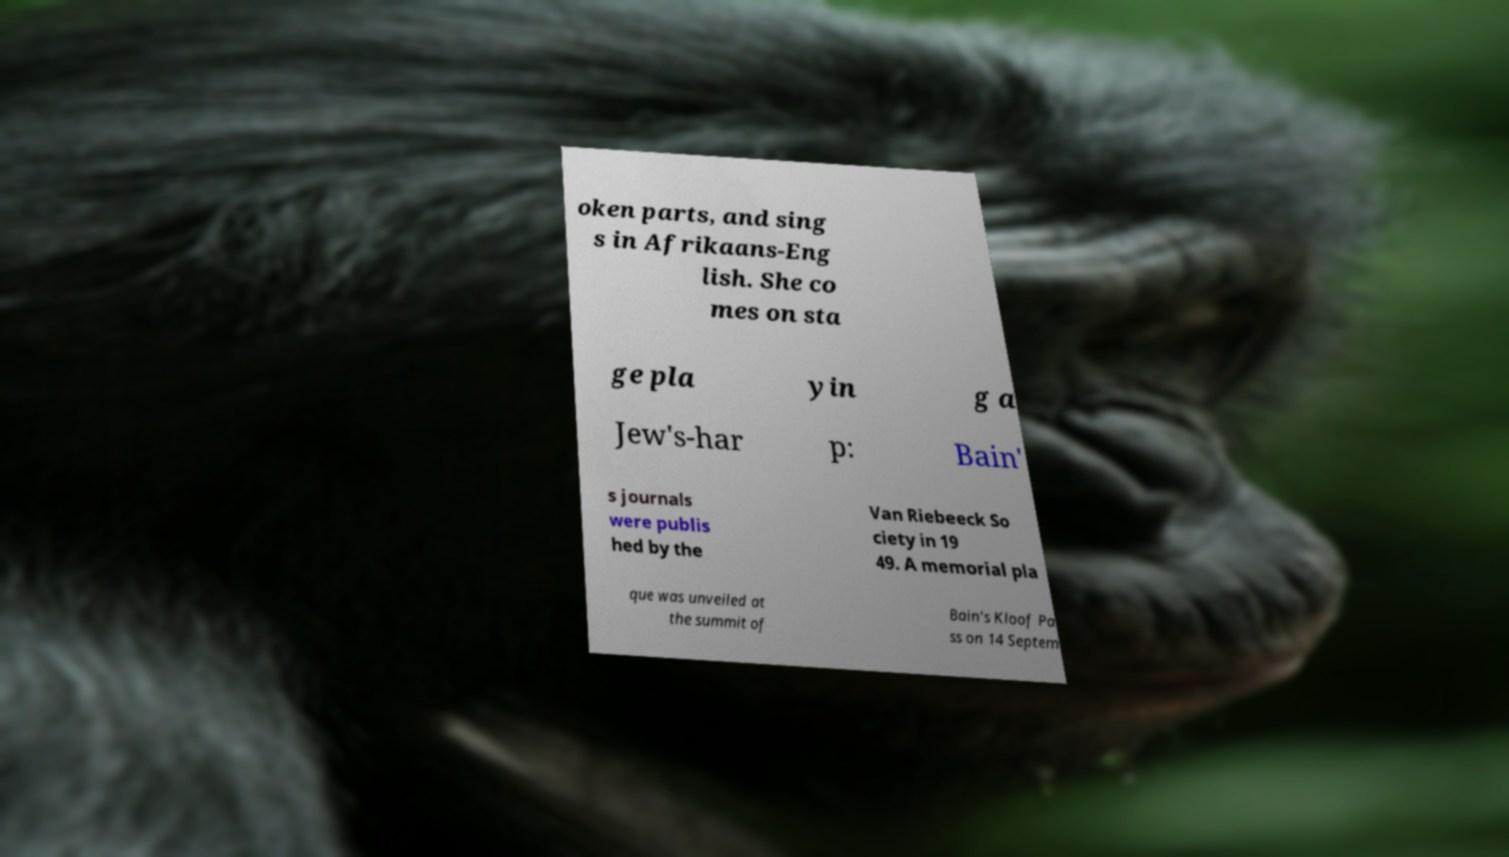Could you extract and type out the text from this image? oken parts, and sing s in Afrikaans-Eng lish. She co mes on sta ge pla yin g a Jew's-har p: Bain' s journals were publis hed by the Van Riebeeck So ciety in 19 49. A memorial pla que was unveiled at the summit of Bain's Kloof Pa ss on 14 Septem 